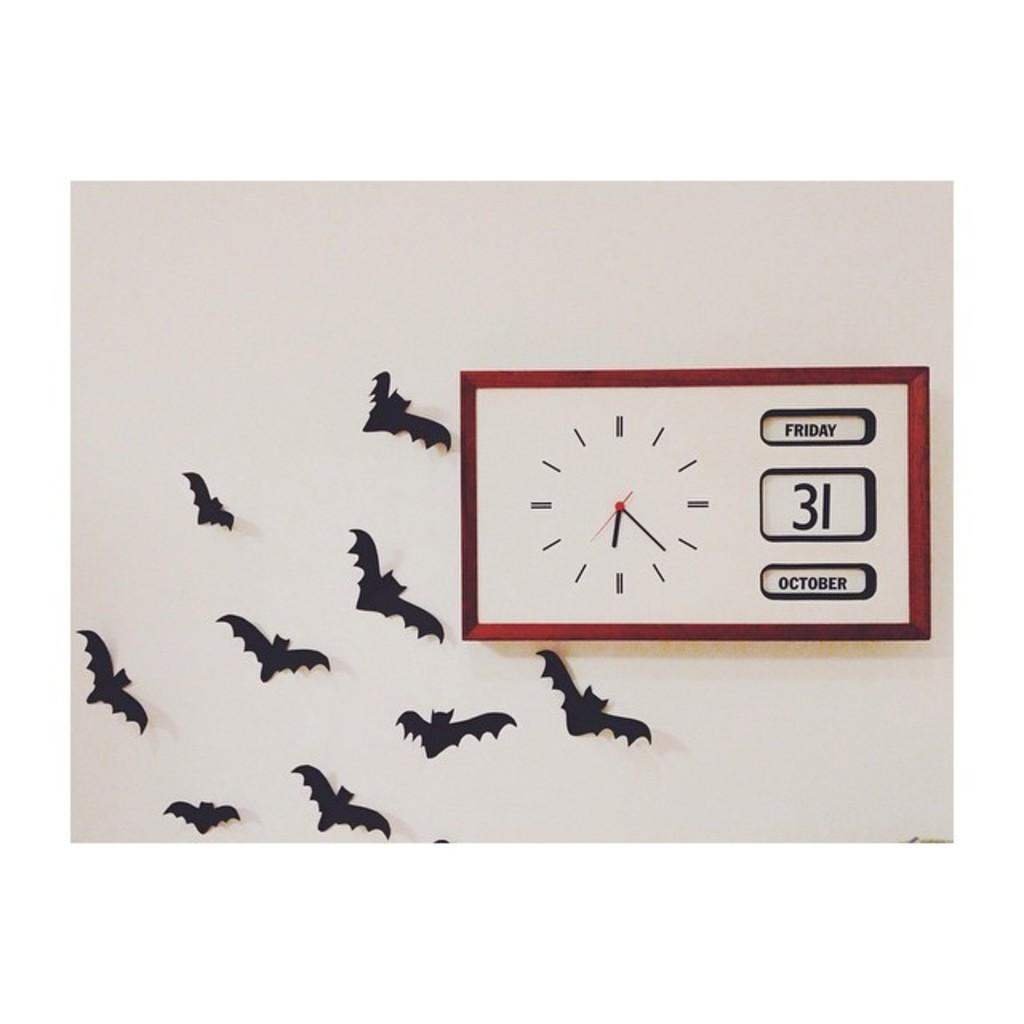<image>
Share a concise interpretation of the image provided. A wall clock showing 6:23, October 31, on a wall with bat silhouettes 